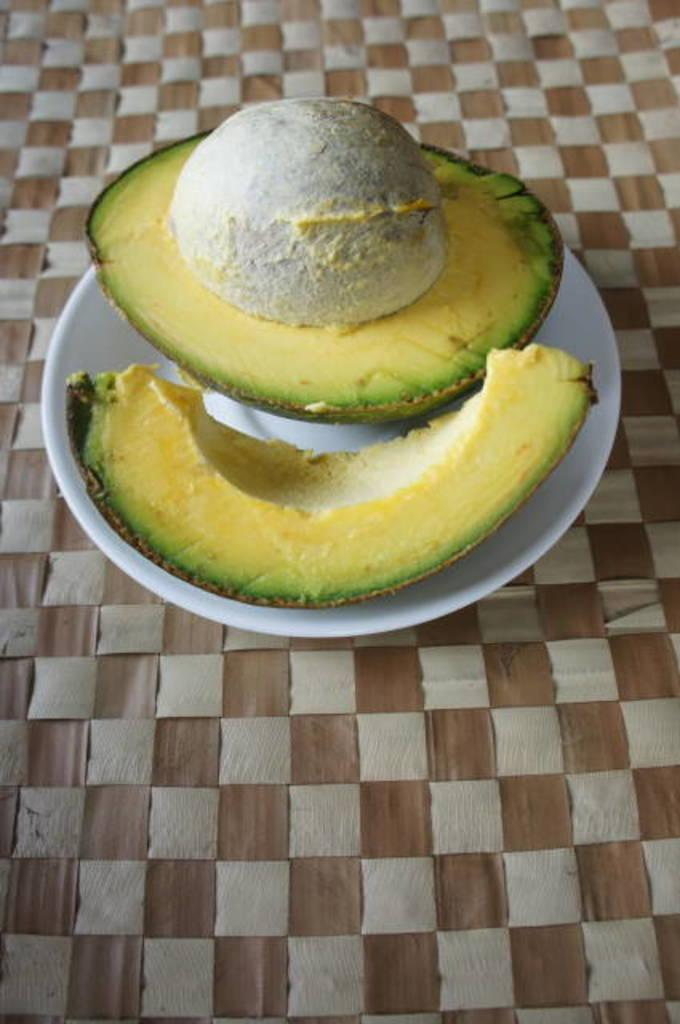What type of food is present in the image? There is a fruit in the image. How is the fruit arranged or displayed in the image? The fruit is placed in a plate. Where is the plate with the fruit located in the image? The plate is on a surface. What creature is competing with the fruit in the image? There is no creature or competition present in the image; it only features a fruit in a plate on a surface. 